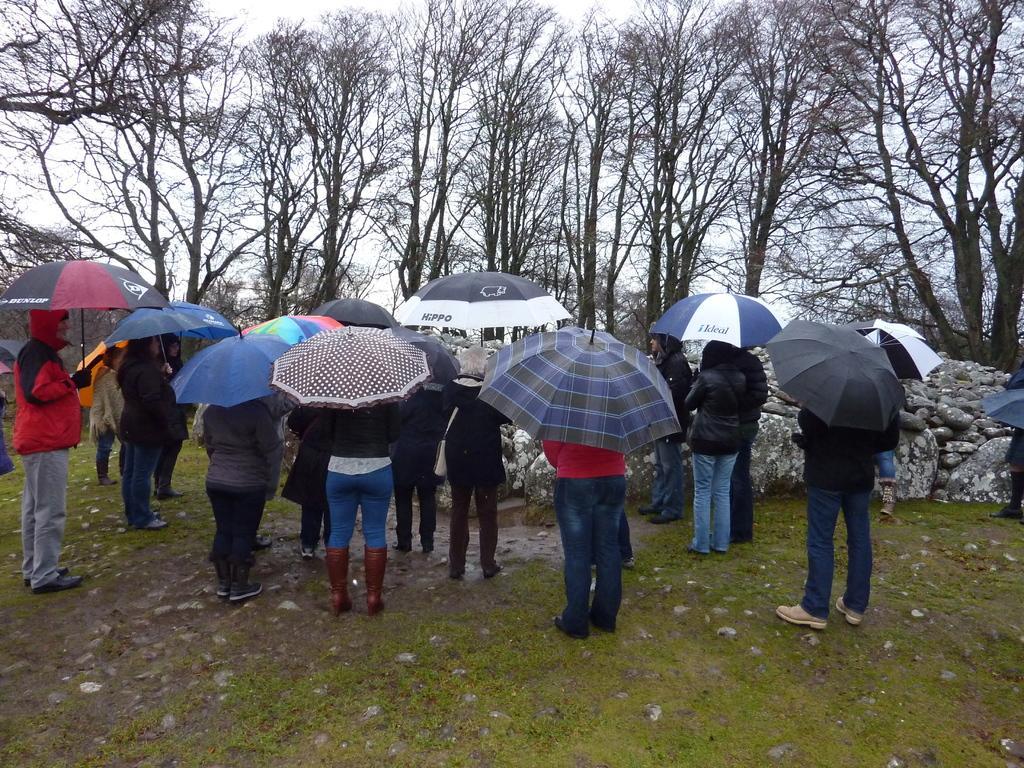Please provide a concise description of this image. In the middle of this image, there are persons holding umbrellas and standing on the ground, on which there are stones and grass. In the background, there are rocks, trees and there are clouds in the sky. 